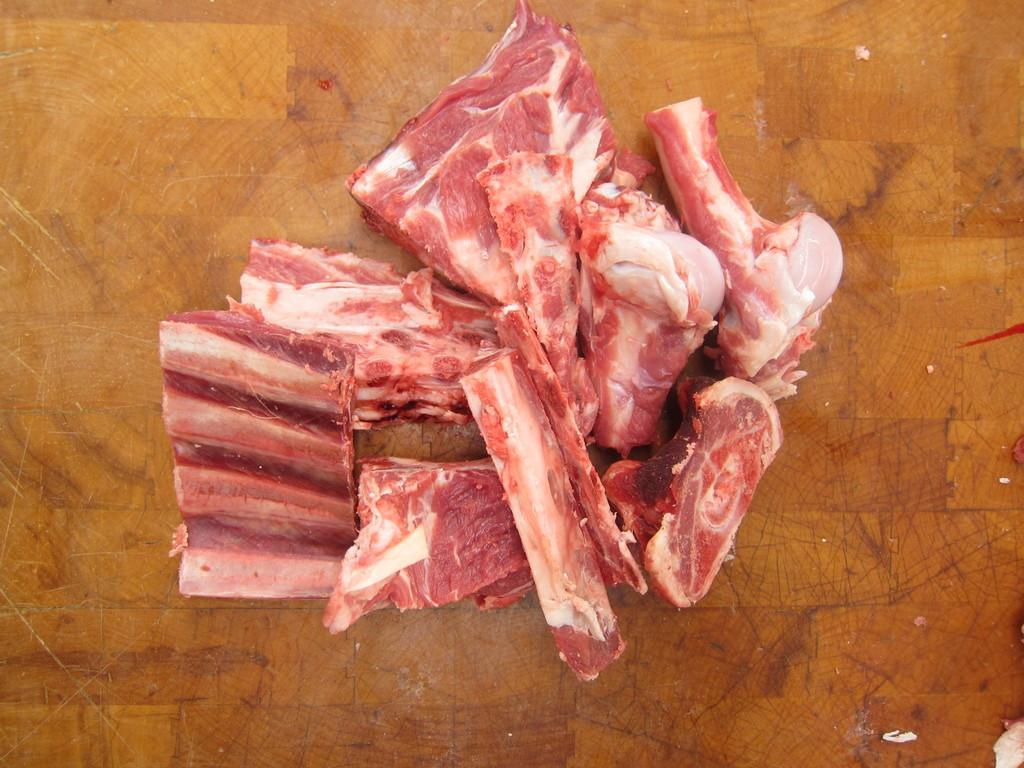Could you give a brief overview of what you see in this image? There is a wooden surface. On that there are pieces of raw meat and bones. 